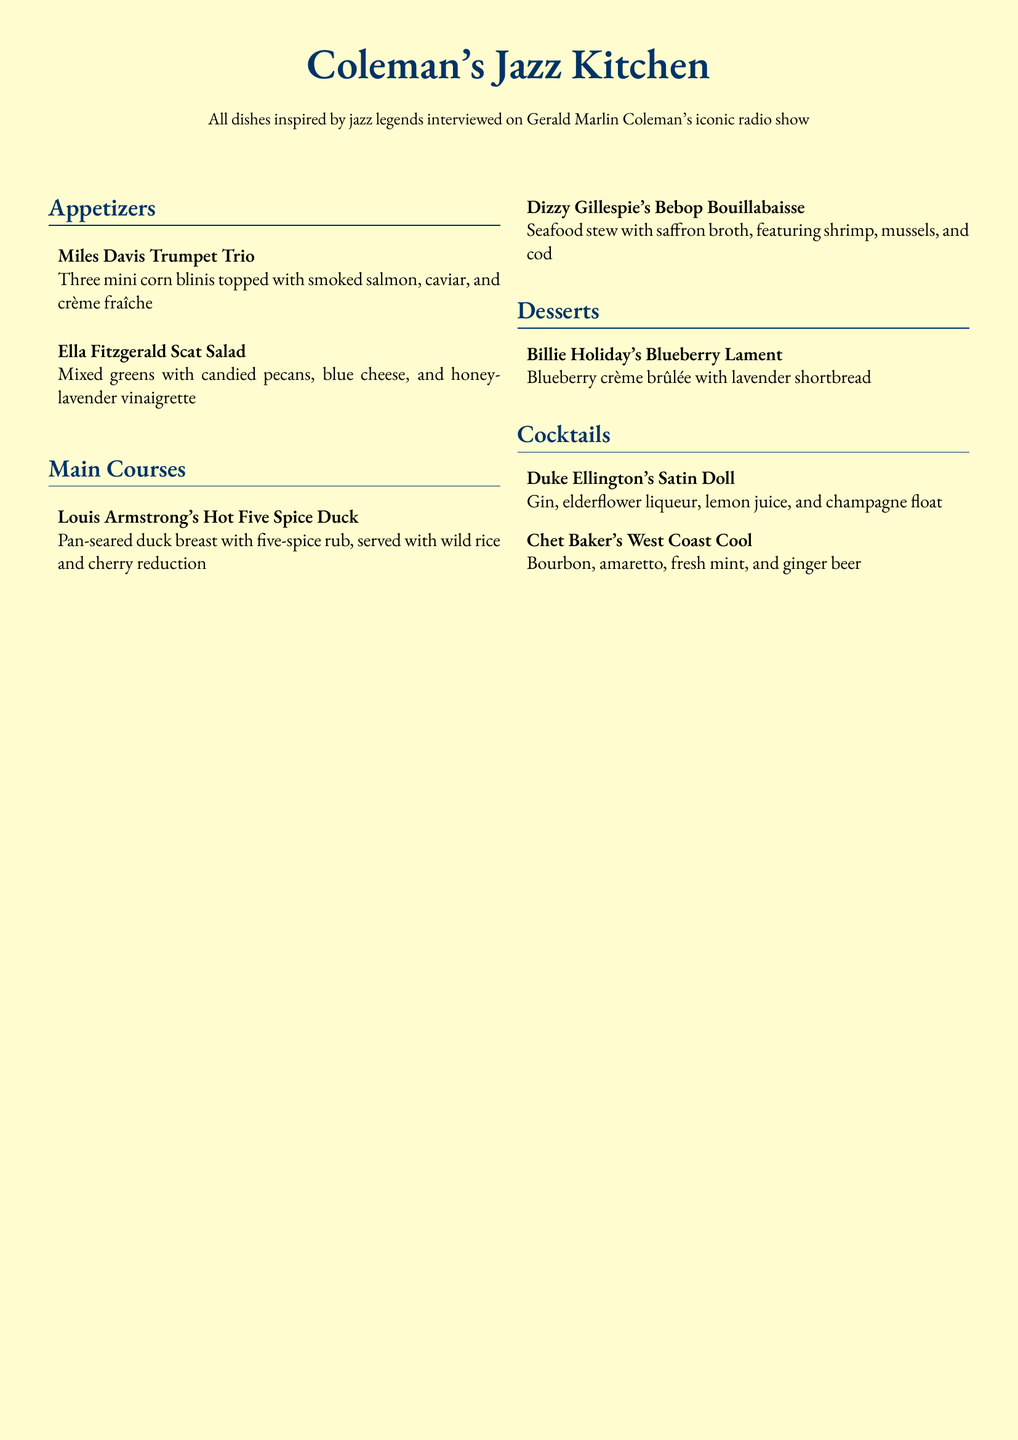What is the name of the restaurant? The name of the restaurant is prominently displayed at the top of the document.
Answer: Coleman's Jazz Kitchen Who is the inspiration behind the dishes? The dishes are inspired by jazz legends interviewed on the radio show of Gerald Marlin Coleman.
Answer: Jazz legends What appetizer features smoked salmon? The document describes various appetizers, highlighting the one topped with smoked salmon specifically.
Answer: Miles Davis Trumpet Trio What main course includes seafood? The available main courses are outlined, and one specifically focuses on a seafood stew.
Answer: Dizzy Gillespie's Bebop Bouillabaisse How many mini corn blinis are served in the appetizer? The appetizer description provides the exact number of mini corn blinis included.
Answer: Three Which cocktail contains bourbon? The cocktails listed include several options; one specifically identifies bourbon in its ingredients.
Answer: Chet Baker's West Coast Cool What dessert is named after Billie Holiday? The dessert section mentions one particular dessert by name that references the iconic artist.
Answer: Billie Holiday's Blueberry Lament What type of salad is offered as an appetizer? The menu describes the type of salad included in the appetizer selection.
Answer: Scat Salad Which dish has a cherry reduction? Among the main courses, one dish is described including a cherry reduction in its preparation.
Answer: Louis Armstrong's Hot Five Spice Duck 